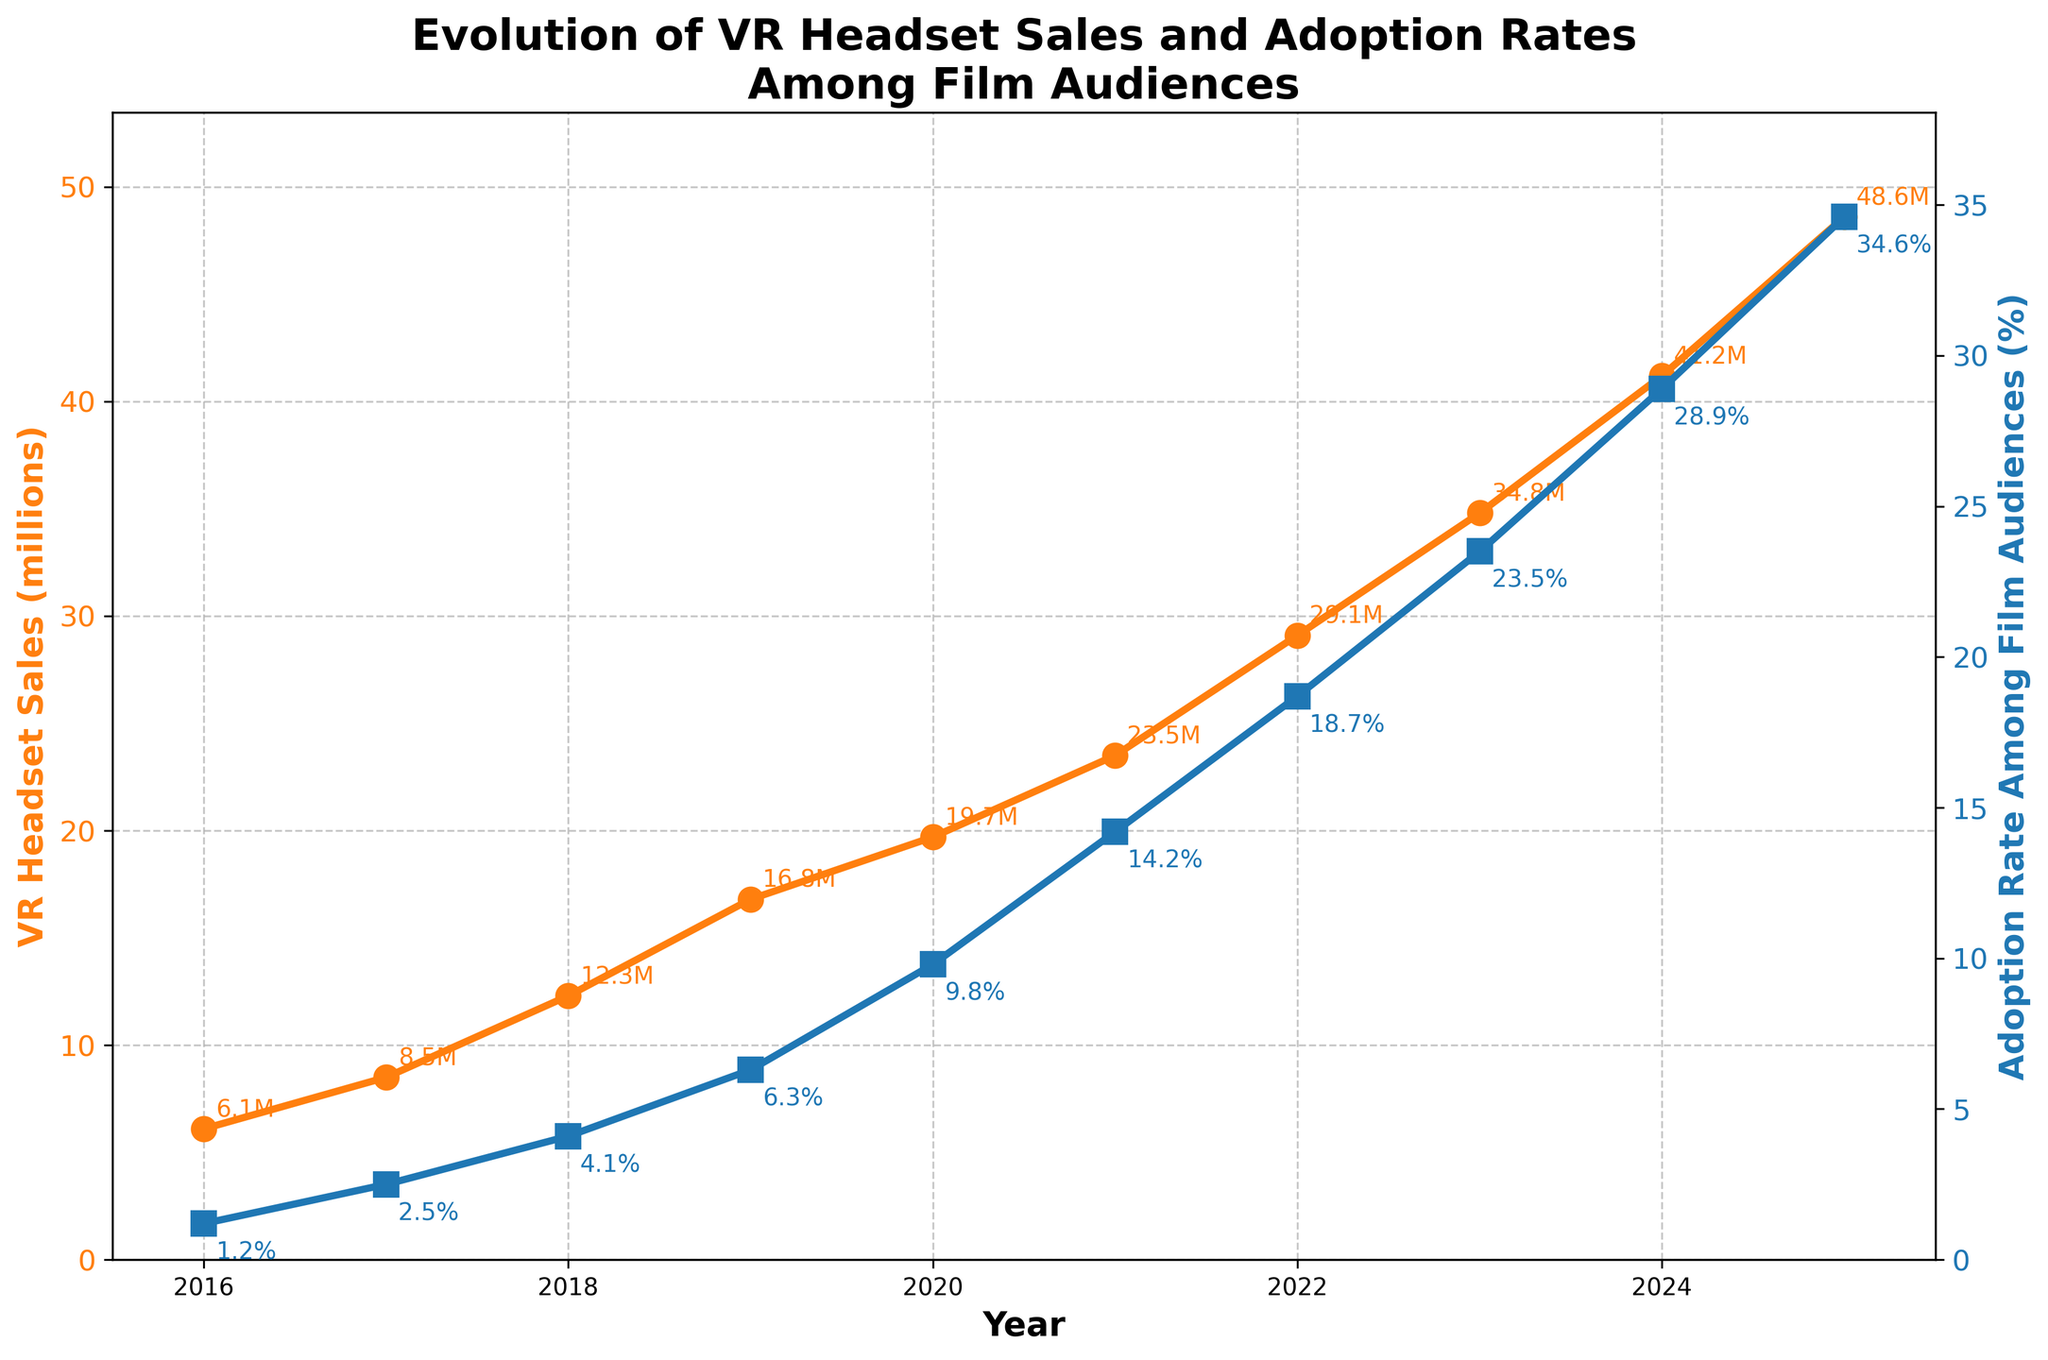What year had the highest VR headset sales according to the figure? Look at the trend of VR headset sales line marked by circles and find the year with the peak value. The highest point corresponds to the year 2025.
Answer: 2025 How much did VR headset sales increase from 2016 to 2020? Subtract the value of VR headset sales in 2016 from the value in 2020. The values are 19.7 million (2020) and 6.1 million (2016), so the difference is 19.7 - 6.1 = 13.6 million.
Answer: 13.6 million Which year shows the largest increase in VR headset sales from the previous year? Compare the difference in VR headset sales between consecutive years. From 2021 to 2022 (29.1 - 23.5) the increase is 5.6 million, which is the largest.
Answer: 2022 What is the trend of the adoption rate among film audiences from 2016 to 2025? By visual inspection, the adoption rate line marked by squares increases steadily each year, implying a consistent upward trend in adoption among film audiences from 1.2% in 2016 to 34.6% in 2025.
Answer: Upward trend In which year did the adoption rate among film audiences surpass 10%? Inspect the adoption rate line and look for the point where it exceeds 10%. It surpassed 10% in 2021 (14.2%).
Answer: 2021 Is the growth rate of VR headset sales higher than that of the adoption rate among film audiences between 2023 and 2024? Calculate the percentage increase for both metrics between these years. VR headset sales increase by (41.2 - 34.8) / 34.8 * 100 = 18.39%, and adoption rate increases by (28.9 - 23.5) / 23.5 * 100 = 22.98%. Adoption rate grows faster.
Answer: No How does the adoption rate among film audiences in 2025 compare to that in 2019? Subtract the adoption rate of 2019 (6.3%) from that of 2025 (34.6%). The difference is 34.6 - 6.3 = 28.3%, indicating a significant increase.
Answer: It increased by 28.3% What is the average VR headset sales from 2016 to 2020? Sum the sales values from 2016 to 2020 and divide by the number of years. (6.1 + 8.5 + 12.3 + 16.8 + 19.7) / 5 = 63.4 / 5 = 12.68 million.
Answer: 12.68 million Which color represents the adoption rate among film audiences in the figure? Identify the color of the line marked by squares representing the adoption rate. The line is blue.
Answer: Blue 